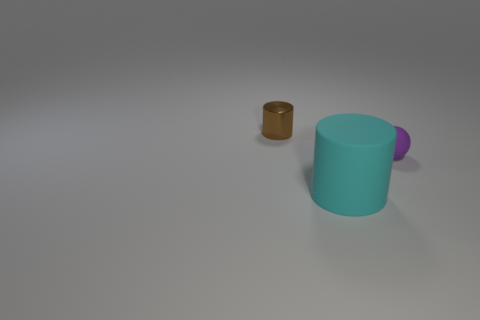Add 1 cyan matte objects. How many objects exist? 4 Subtract all spheres. How many objects are left? 2 Add 2 small cyan rubber spheres. How many small cyan rubber spheres exist? 2 Subtract 0 gray cubes. How many objects are left? 3 Subtract all green rubber cubes. Subtract all tiny purple objects. How many objects are left? 2 Add 2 small purple matte balls. How many small purple matte balls are left? 3 